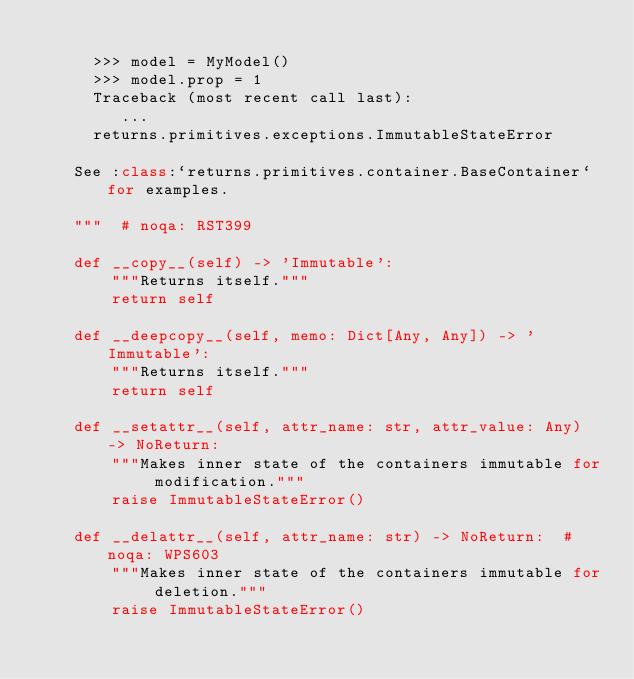<code> <loc_0><loc_0><loc_500><loc_500><_Python_>
      >>> model = MyModel()
      >>> model.prop = 1
      Traceback (most recent call last):
         ...
      returns.primitives.exceptions.ImmutableStateError

    See :class:`returns.primitives.container.BaseContainer` for examples.

    """  # noqa: RST399

    def __copy__(self) -> 'Immutable':
        """Returns itself."""
        return self

    def __deepcopy__(self, memo: Dict[Any, Any]) -> 'Immutable':
        """Returns itself."""
        return self

    def __setattr__(self, attr_name: str, attr_value: Any) -> NoReturn:
        """Makes inner state of the containers immutable for modification."""
        raise ImmutableStateError()

    def __delattr__(self, attr_name: str) -> NoReturn:  # noqa: WPS603
        """Makes inner state of the containers immutable for deletion."""
        raise ImmutableStateError()
</code> 